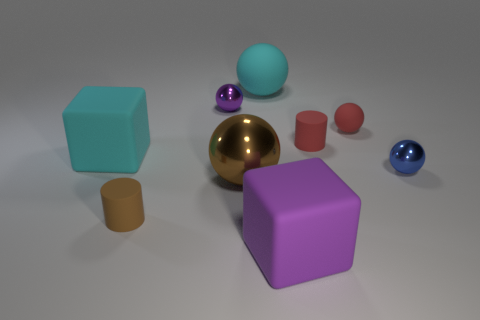Subtract all large spheres. How many spheres are left? 3 Subtract all brown spheres. How many spheres are left? 4 Subtract all red spheres. Subtract all cyan cylinders. How many spheres are left? 4 Subtract all spheres. How many objects are left? 4 Add 5 big cyan rubber blocks. How many big cyan rubber blocks are left? 6 Add 8 tiny red things. How many tiny red things exist? 10 Subtract 0 green cylinders. How many objects are left? 9 Subtract all large brown balls. Subtract all tiny red cylinders. How many objects are left? 7 